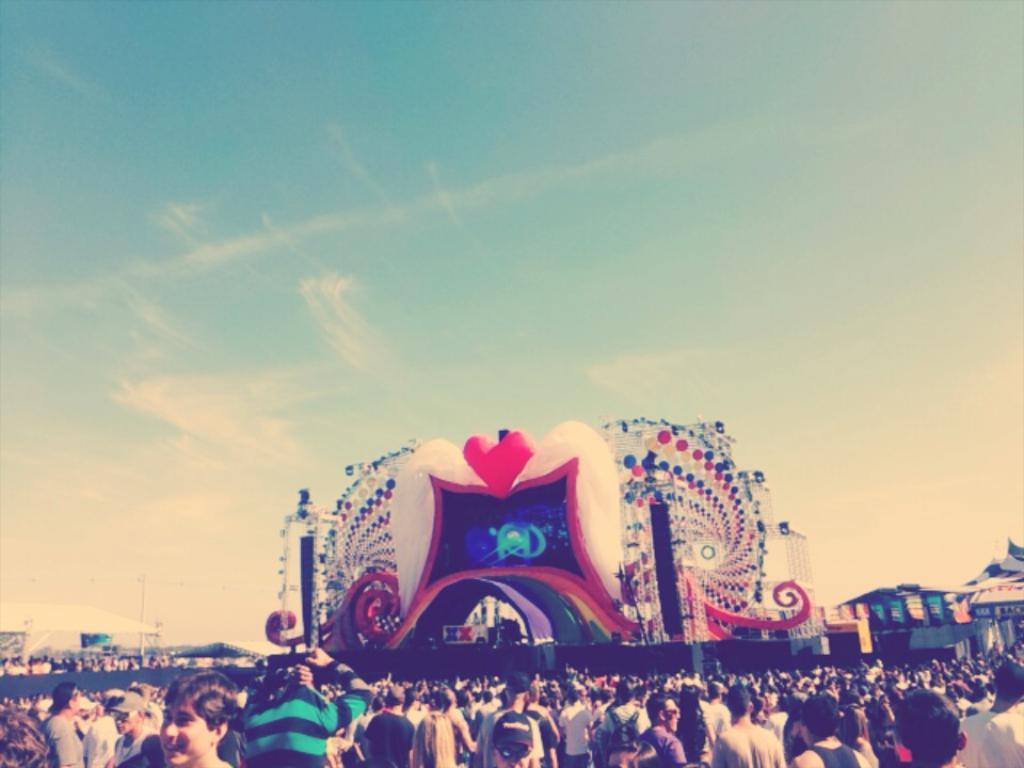How would you summarize this image in a sentence or two? In the image in the center, we can see some architecture. And we can see a group of people are standing. In the background we can see the sky, clouds, tents etc. 